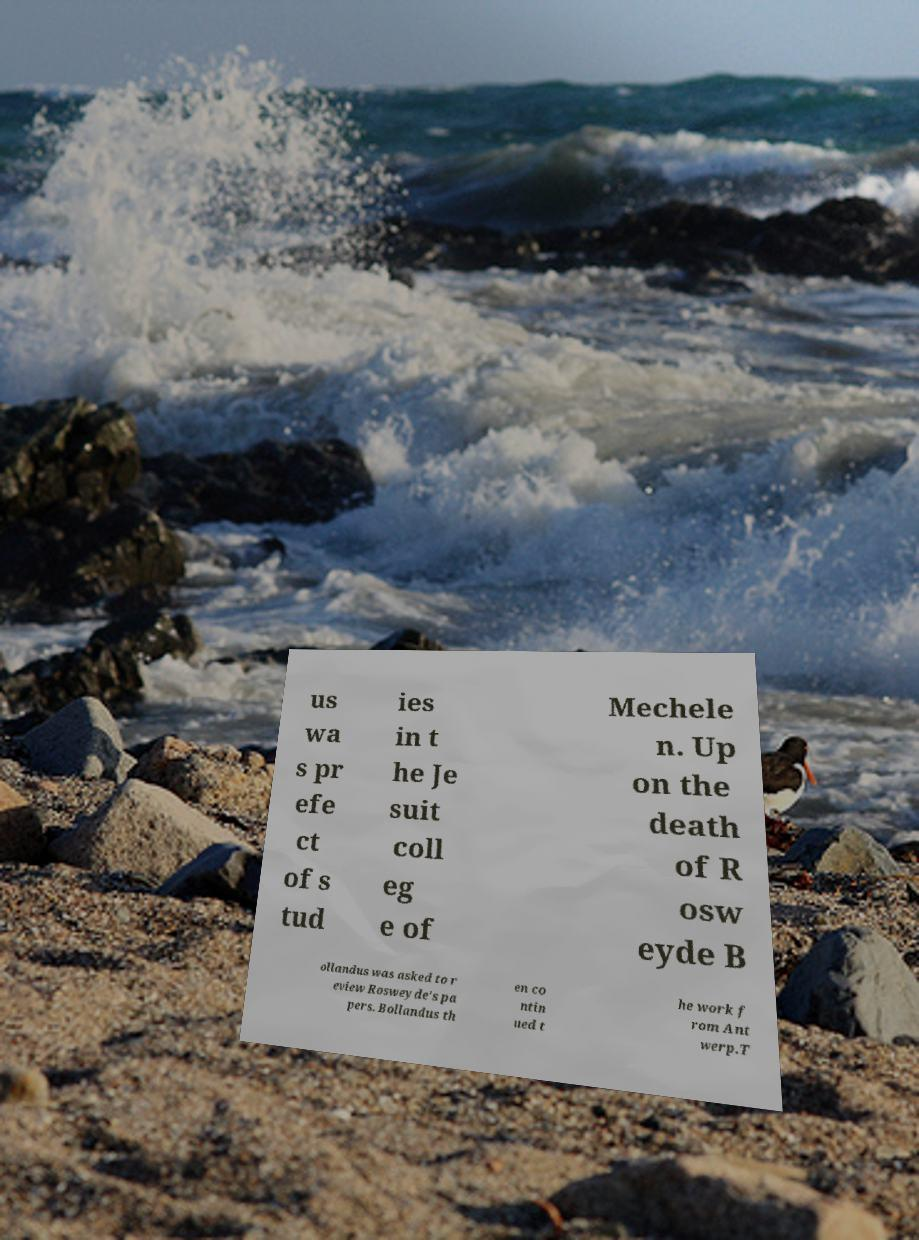For documentation purposes, I need the text within this image transcribed. Could you provide that? us wa s pr efe ct of s tud ies in t he Je suit coll eg e of Mechele n. Up on the death of R osw eyde B ollandus was asked to r eview Rosweyde's pa pers. Bollandus th en co ntin ued t he work f rom Ant werp.T 